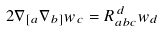<formula> <loc_0><loc_0><loc_500><loc_500>2 \nabla _ { [ a } \nabla _ { b ] } w _ { c } = R _ { a b c } ^ { \, d } w _ { d }</formula> 